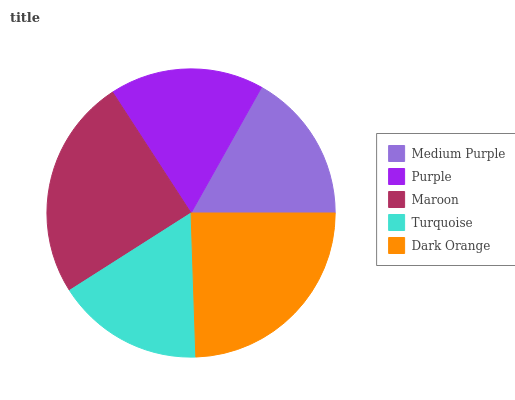Is Turquoise the minimum?
Answer yes or no. Yes. Is Maroon the maximum?
Answer yes or no. Yes. Is Purple the minimum?
Answer yes or no. No. Is Purple the maximum?
Answer yes or no. No. Is Purple greater than Medium Purple?
Answer yes or no. Yes. Is Medium Purple less than Purple?
Answer yes or no. Yes. Is Medium Purple greater than Purple?
Answer yes or no. No. Is Purple less than Medium Purple?
Answer yes or no. No. Is Purple the high median?
Answer yes or no. Yes. Is Purple the low median?
Answer yes or no. Yes. Is Maroon the high median?
Answer yes or no. No. Is Dark Orange the low median?
Answer yes or no. No. 